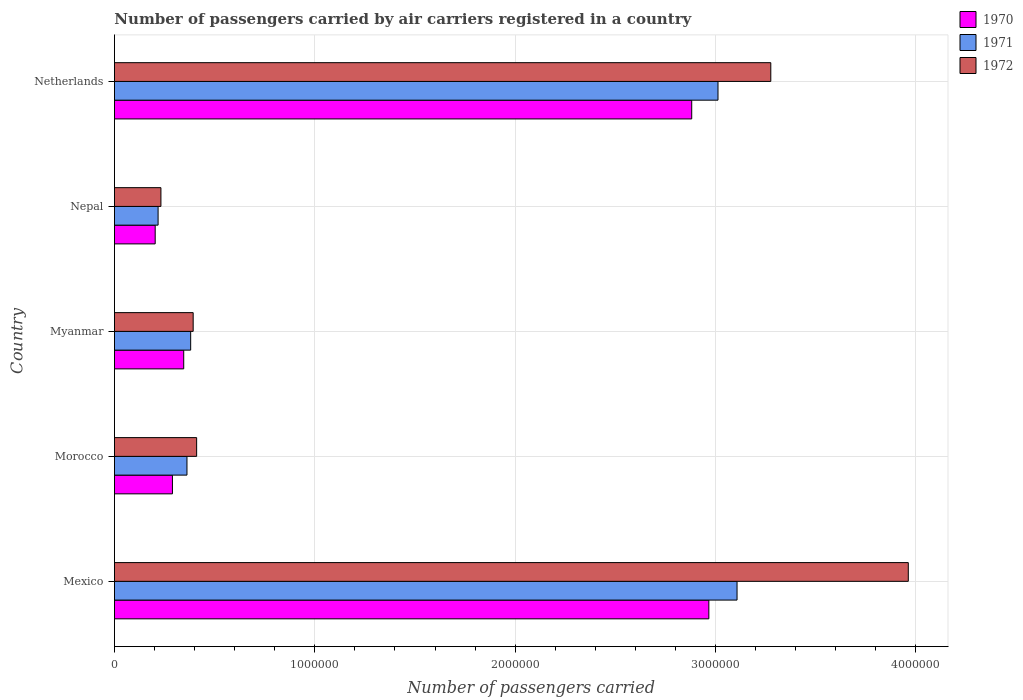How many groups of bars are there?
Offer a very short reply. 5. Are the number of bars per tick equal to the number of legend labels?
Your response must be concise. Yes. Are the number of bars on each tick of the Y-axis equal?
Your answer should be compact. Yes. What is the label of the 3rd group of bars from the top?
Your response must be concise. Myanmar. In how many cases, is the number of bars for a given country not equal to the number of legend labels?
Your answer should be compact. 0. What is the number of passengers carried by air carriers in 1972 in Mexico?
Make the answer very short. 3.96e+06. Across all countries, what is the maximum number of passengers carried by air carriers in 1972?
Give a very brief answer. 3.96e+06. Across all countries, what is the minimum number of passengers carried by air carriers in 1972?
Your answer should be compact. 2.32e+05. In which country was the number of passengers carried by air carriers in 1971 maximum?
Your answer should be compact. Mexico. In which country was the number of passengers carried by air carriers in 1971 minimum?
Your answer should be very brief. Nepal. What is the total number of passengers carried by air carriers in 1972 in the graph?
Your answer should be very brief. 8.27e+06. What is the difference between the number of passengers carried by air carriers in 1970 in Morocco and that in Netherlands?
Give a very brief answer. -2.59e+06. What is the difference between the number of passengers carried by air carriers in 1971 in Nepal and the number of passengers carried by air carriers in 1970 in Mexico?
Your answer should be compact. -2.75e+06. What is the average number of passengers carried by air carriers in 1971 per country?
Provide a short and direct response. 1.42e+06. What is the difference between the number of passengers carried by air carriers in 1972 and number of passengers carried by air carriers in 1970 in Myanmar?
Give a very brief answer. 4.72e+04. In how many countries, is the number of passengers carried by air carriers in 1971 greater than 1000000 ?
Provide a short and direct response. 2. What is the ratio of the number of passengers carried by air carriers in 1971 in Nepal to that in Netherlands?
Offer a very short reply. 0.07. What is the difference between the highest and the second highest number of passengers carried by air carriers in 1972?
Make the answer very short. 6.86e+05. What is the difference between the highest and the lowest number of passengers carried by air carriers in 1971?
Provide a succinct answer. 2.89e+06. In how many countries, is the number of passengers carried by air carriers in 1971 greater than the average number of passengers carried by air carriers in 1971 taken over all countries?
Ensure brevity in your answer.  2. Is the sum of the number of passengers carried by air carriers in 1970 in Mexico and Myanmar greater than the maximum number of passengers carried by air carriers in 1971 across all countries?
Provide a succinct answer. Yes. How many bars are there?
Provide a short and direct response. 15. How many countries are there in the graph?
Make the answer very short. 5. What is the difference between two consecutive major ticks on the X-axis?
Keep it short and to the point. 1.00e+06. Does the graph contain any zero values?
Keep it short and to the point. No. Where does the legend appear in the graph?
Your answer should be compact. Top right. How are the legend labels stacked?
Ensure brevity in your answer.  Vertical. What is the title of the graph?
Keep it short and to the point. Number of passengers carried by air carriers registered in a country. Does "1974" appear as one of the legend labels in the graph?
Keep it short and to the point. No. What is the label or title of the X-axis?
Give a very brief answer. Number of passengers carried. What is the Number of passengers carried of 1970 in Mexico?
Your answer should be compact. 2.97e+06. What is the Number of passengers carried in 1971 in Mexico?
Your answer should be very brief. 3.11e+06. What is the Number of passengers carried of 1972 in Mexico?
Keep it short and to the point. 3.96e+06. What is the Number of passengers carried in 1970 in Morocco?
Your response must be concise. 2.90e+05. What is the Number of passengers carried of 1971 in Morocco?
Make the answer very short. 3.62e+05. What is the Number of passengers carried in 1972 in Morocco?
Your answer should be compact. 4.10e+05. What is the Number of passengers carried in 1970 in Myanmar?
Keep it short and to the point. 3.46e+05. What is the Number of passengers carried in 1971 in Myanmar?
Provide a succinct answer. 3.80e+05. What is the Number of passengers carried in 1972 in Myanmar?
Your answer should be very brief. 3.93e+05. What is the Number of passengers carried of 1970 in Nepal?
Your response must be concise. 2.03e+05. What is the Number of passengers carried in 1971 in Nepal?
Offer a very short reply. 2.18e+05. What is the Number of passengers carried of 1972 in Nepal?
Ensure brevity in your answer.  2.32e+05. What is the Number of passengers carried of 1970 in Netherlands?
Provide a succinct answer. 2.88e+06. What is the Number of passengers carried of 1971 in Netherlands?
Offer a terse response. 3.01e+06. What is the Number of passengers carried in 1972 in Netherlands?
Your answer should be compact. 3.28e+06. Across all countries, what is the maximum Number of passengers carried in 1970?
Offer a terse response. 2.97e+06. Across all countries, what is the maximum Number of passengers carried of 1971?
Offer a very short reply. 3.11e+06. Across all countries, what is the maximum Number of passengers carried of 1972?
Offer a very short reply. 3.96e+06. Across all countries, what is the minimum Number of passengers carried in 1970?
Your response must be concise. 2.03e+05. Across all countries, what is the minimum Number of passengers carried in 1971?
Ensure brevity in your answer.  2.18e+05. Across all countries, what is the minimum Number of passengers carried in 1972?
Offer a terse response. 2.32e+05. What is the total Number of passengers carried of 1970 in the graph?
Provide a succinct answer. 6.69e+06. What is the total Number of passengers carried in 1971 in the graph?
Offer a very short reply. 7.08e+06. What is the total Number of passengers carried of 1972 in the graph?
Give a very brief answer. 8.27e+06. What is the difference between the Number of passengers carried in 1970 in Mexico and that in Morocco?
Offer a very short reply. 2.68e+06. What is the difference between the Number of passengers carried in 1971 in Mexico and that in Morocco?
Provide a succinct answer. 2.75e+06. What is the difference between the Number of passengers carried in 1972 in Mexico and that in Morocco?
Offer a very short reply. 3.55e+06. What is the difference between the Number of passengers carried of 1970 in Mexico and that in Myanmar?
Provide a short and direct response. 2.62e+06. What is the difference between the Number of passengers carried in 1971 in Mexico and that in Myanmar?
Provide a succinct answer. 2.73e+06. What is the difference between the Number of passengers carried of 1972 in Mexico and that in Myanmar?
Provide a succinct answer. 3.57e+06. What is the difference between the Number of passengers carried in 1970 in Mexico and that in Nepal?
Offer a terse response. 2.76e+06. What is the difference between the Number of passengers carried in 1971 in Mexico and that in Nepal?
Your answer should be compact. 2.89e+06. What is the difference between the Number of passengers carried of 1972 in Mexico and that in Nepal?
Ensure brevity in your answer.  3.73e+06. What is the difference between the Number of passengers carried in 1970 in Mexico and that in Netherlands?
Provide a succinct answer. 8.55e+04. What is the difference between the Number of passengers carried in 1971 in Mexico and that in Netherlands?
Offer a very short reply. 9.50e+04. What is the difference between the Number of passengers carried of 1972 in Mexico and that in Netherlands?
Keep it short and to the point. 6.86e+05. What is the difference between the Number of passengers carried in 1970 in Morocco and that in Myanmar?
Offer a terse response. -5.63e+04. What is the difference between the Number of passengers carried in 1971 in Morocco and that in Myanmar?
Provide a succinct answer. -1.85e+04. What is the difference between the Number of passengers carried in 1972 in Morocco and that in Myanmar?
Keep it short and to the point. 1.73e+04. What is the difference between the Number of passengers carried of 1970 in Morocco and that in Nepal?
Ensure brevity in your answer.  8.61e+04. What is the difference between the Number of passengers carried of 1971 in Morocco and that in Nepal?
Offer a terse response. 1.44e+05. What is the difference between the Number of passengers carried of 1972 in Morocco and that in Nepal?
Your answer should be compact. 1.78e+05. What is the difference between the Number of passengers carried of 1970 in Morocco and that in Netherlands?
Ensure brevity in your answer.  -2.59e+06. What is the difference between the Number of passengers carried of 1971 in Morocco and that in Netherlands?
Your answer should be very brief. -2.65e+06. What is the difference between the Number of passengers carried of 1972 in Morocco and that in Netherlands?
Keep it short and to the point. -2.87e+06. What is the difference between the Number of passengers carried of 1970 in Myanmar and that in Nepal?
Keep it short and to the point. 1.42e+05. What is the difference between the Number of passengers carried in 1971 in Myanmar and that in Nepal?
Offer a terse response. 1.63e+05. What is the difference between the Number of passengers carried in 1972 in Myanmar and that in Nepal?
Your answer should be very brief. 1.61e+05. What is the difference between the Number of passengers carried in 1970 in Myanmar and that in Netherlands?
Offer a terse response. -2.54e+06. What is the difference between the Number of passengers carried in 1971 in Myanmar and that in Netherlands?
Make the answer very short. -2.63e+06. What is the difference between the Number of passengers carried in 1972 in Myanmar and that in Netherlands?
Make the answer very short. -2.88e+06. What is the difference between the Number of passengers carried in 1970 in Nepal and that in Netherlands?
Your answer should be compact. -2.68e+06. What is the difference between the Number of passengers carried of 1971 in Nepal and that in Netherlands?
Your answer should be very brief. -2.79e+06. What is the difference between the Number of passengers carried of 1972 in Nepal and that in Netherlands?
Provide a short and direct response. -3.04e+06. What is the difference between the Number of passengers carried in 1970 in Mexico and the Number of passengers carried in 1971 in Morocco?
Provide a short and direct response. 2.60e+06. What is the difference between the Number of passengers carried in 1970 in Mexico and the Number of passengers carried in 1972 in Morocco?
Your response must be concise. 2.56e+06. What is the difference between the Number of passengers carried of 1971 in Mexico and the Number of passengers carried of 1972 in Morocco?
Keep it short and to the point. 2.70e+06. What is the difference between the Number of passengers carried in 1970 in Mexico and the Number of passengers carried in 1971 in Myanmar?
Your answer should be compact. 2.59e+06. What is the difference between the Number of passengers carried of 1970 in Mexico and the Number of passengers carried of 1972 in Myanmar?
Ensure brevity in your answer.  2.57e+06. What is the difference between the Number of passengers carried of 1971 in Mexico and the Number of passengers carried of 1972 in Myanmar?
Offer a very short reply. 2.71e+06. What is the difference between the Number of passengers carried of 1970 in Mexico and the Number of passengers carried of 1971 in Nepal?
Give a very brief answer. 2.75e+06. What is the difference between the Number of passengers carried of 1970 in Mexico and the Number of passengers carried of 1972 in Nepal?
Make the answer very short. 2.73e+06. What is the difference between the Number of passengers carried of 1971 in Mexico and the Number of passengers carried of 1972 in Nepal?
Ensure brevity in your answer.  2.88e+06. What is the difference between the Number of passengers carried in 1970 in Mexico and the Number of passengers carried in 1971 in Netherlands?
Give a very brief answer. -4.57e+04. What is the difference between the Number of passengers carried of 1970 in Mexico and the Number of passengers carried of 1972 in Netherlands?
Offer a very short reply. -3.09e+05. What is the difference between the Number of passengers carried in 1971 in Mexico and the Number of passengers carried in 1972 in Netherlands?
Ensure brevity in your answer.  -1.68e+05. What is the difference between the Number of passengers carried of 1970 in Morocco and the Number of passengers carried of 1971 in Myanmar?
Offer a very short reply. -9.10e+04. What is the difference between the Number of passengers carried in 1970 in Morocco and the Number of passengers carried in 1972 in Myanmar?
Your answer should be very brief. -1.04e+05. What is the difference between the Number of passengers carried of 1971 in Morocco and the Number of passengers carried of 1972 in Myanmar?
Your answer should be compact. -3.10e+04. What is the difference between the Number of passengers carried of 1970 in Morocco and the Number of passengers carried of 1971 in Nepal?
Keep it short and to the point. 7.16e+04. What is the difference between the Number of passengers carried of 1970 in Morocco and the Number of passengers carried of 1972 in Nepal?
Provide a succinct answer. 5.75e+04. What is the difference between the Number of passengers carried in 1970 in Morocco and the Number of passengers carried in 1971 in Netherlands?
Your response must be concise. -2.72e+06. What is the difference between the Number of passengers carried in 1970 in Morocco and the Number of passengers carried in 1972 in Netherlands?
Ensure brevity in your answer.  -2.99e+06. What is the difference between the Number of passengers carried in 1971 in Morocco and the Number of passengers carried in 1972 in Netherlands?
Your response must be concise. -2.91e+06. What is the difference between the Number of passengers carried of 1970 in Myanmar and the Number of passengers carried of 1971 in Nepal?
Your answer should be very brief. 1.28e+05. What is the difference between the Number of passengers carried in 1970 in Myanmar and the Number of passengers carried in 1972 in Nepal?
Keep it short and to the point. 1.14e+05. What is the difference between the Number of passengers carried in 1971 in Myanmar and the Number of passengers carried in 1972 in Nepal?
Provide a succinct answer. 1.48e+05. What is the difference between the Number of passengers carried of 1970 in Myanmar and the Number of passengers carried of 1971 in Netherlands?
Give a very brief answer. -2.67e+06. What is the difference between the Number of passengers carried in 1970 in Myanmar and the Number of passengers carried in 1972 in Netherlands?
Your answer should be very brief. -2.93e+06. What is the difference between the Number of passengers carried in 1971 in Myanmar and the Number of passengers carried in 1972 in Netherlands?
Ensure brevity in your answer.  -2.90e+06. What is the difference between the Number of passengers carried in 1970 in Nepal and the Number of passengers carried in 1971 in Netherlands?
Make the answer very short. -2.81e+06. What is the difference between the Number of passengers carried in 1970 in Nepal and the Number of passengers carried in 1972 in Netherlands?
Provide a succinct answer. -3.07e+06. What is the difference between the Number of passengers carried in 1971 in Nepal and the Number of passengers carried in 1972 in Netherlands?
Give a very brief answer. -3.06e+06. What is the average Number of passengers carried of 1970 per country?
Give a very brief answer. 1.34e+06. What is the average Number of passengers carried in 1971 per country?
Offer a terse response. 1.42e+06. What is the average Number of passengers carried in 1972 per country?
Ensure brevity in your answer.  1.65e+06. What is the difference between the Number of passengers carried of 1970 and Number of passengers carried of 1971 in Mexico?
Your answer should be compact. -1.41e+05. What is the difference between the Number of passengers carried of 1970 and Number of passengers carried of 1972 in Mexico?
Make the answer very short. -9.95e+05. What is the difference between the Number of passengers carried of 1971 and Number of passengers carried of 1972 in Mexico?
Provide a succinct answer. -8.55e+05. What is the difference between the Number of passengers carried of 1970 and Number of passengers carried of 1971 in Morocco?
Provide a succinct answer. -7.25e+04. What is the difference between the Number of passengers carried in 1970 and Number of passengers carried in 1972 in Morocco?
Offer a very short reply. -1.21e+05. What is the difference between the Number of passengers carried in 1971 and Number of passengers carried in 1972 in Morocco?
Provide a succinct answer. -4.83e+04. What is the difference between the Number of passengers carried in 1970 and Number of passengers carried in 1971 in Myanmar?
Your response must be concise. -3.47e+04. What is the difference between the Number of passengers carried of 1970 and Number of passengers carried of 1972 in Myanmar?
Offer a very short reply. -4.72e+04. What is the difference between the Number of passengers carried in 1971 and Number of passengers carried in 1972 in Myanmar?
Provide a short and direct response. -1.25e+04. What is the difference between the Number of passengers carried in 1970 and Number of passengers carried in 1971 in Nepal?
Give a very brief answer. -1.45e+04. What is the difference between the Number of passengers carried in 1970 and Number of passengers carried in 1972 in Nepal?
Your answer should be compact. -2.86e+04. What is the difference between the Number of passengers carried in 1971 and Number of passengers carried in 1972 in Nepal?
Provide a succinct answer. -1.41e+04. What is the difference between the Number of passengers carried in 1970 and Number of passengers carried in 1971 in Netherlands?
Your response must be concise. -1.31e+05. What is the difference between the Number of passengers carried of 1970 and Number of passengers carried of 1972 in Netherlands?
Ensure brevity in your answer.  -3.95e+05. What is the difference between the Number of passengers carried in 1971 and Number of passengers carried in 1972 in Netherlands?
Give a very brief answer. -2.64e+05. What is the ratio of the Number of passengers carried in 1970 in Mexico to that in Morocco?
Your answer should be very brief. 10.25. What is the ratio of the Number of passengers carried of 1971 in Mexico to that in Morocco?
Offer a very short reply. 8.58. What is the ratio of the Number of passengers carried in 1972 in Mexico to that in Morocco?
Give a very brief answer. 9.66. What is the ratio of the Number of passengers carried in 1970 in Mexico to that in Myanmar?
Offer a terse response. 8.58. What is the ratio of the Number of passengers carried of 1971 in Mexico to that in Myanmar?
Offer a very short reply. 8.17. What is the ratio of the Number of passengers carried in 1972 in Mexico to that in Myanmar?
Provide a succinct answer. 10.08. What is the ratio of the Number of passengers carried of 1970 in Mexico to that in Nepal?
Keep it short and to the point. 14.59. What is the ratio of the Number of passengers carried in 1971 in Mexico to that in Nepal?
Provide a succinct answer. 14.26. What is the ratio of the Number of passengers carried of 1972 in Mexico to that in Nepal?
Provide a short and direct response. 17.08. What is the ratio of the Number of passengers carried in 1970 in Mexico to that in Netherlands?
Make the answer very short. 1.03. What is the ratio of the Number of passengers carried in 1971 in Mexico to that in Netherlands?
Give a very brief answer. 1.03. What is the ratio of the Number of passengers carried in 1972 in Mexico to that in Netherlands?
Make the answer very short. 1.21. What is the ratio of the Number of passengers carried in 1970 in Morocco to that in Myanmar?
Offer a terse response. 0.84. What is the ratio of the Number of passengers carried in 1971 in Morocco to that in Myanmar?
Ensure brevity in your answer.  0.95. What is the ratio of the Number of passengers carried of 1972 in Morocco to that in Myanmar?
Offer a terse response. 1.04. What is the ratio of the Number of passengers carried of 1970 in Morocco to that in Nepal?
Ensure brevity in your answer.  1.42. What is the ratio of the Number of passengers carried in 1971 in Morocco to that in Nepal?
Provide a succinct answer. 1.66. What is the ratio of the Number of passengers carried of 1972 in Morocco to that in Nepal?
Offer a very short reply. 1.77. What is the ratio of the Number of passengers carried of 1970 in Morocco to that in Netherlands?
Offer a terse response. 0.1. What is the ratio of the Number of passengers carried of 1971 in Morocco to that in Netherlands?
Offer a terse response. 0.12. What is the ratio of the Number of passengers carried in 1972 in Morocco to that in Netherlands?
Ensure brevity in your answer.  0.13. What is the ratio of the Number of passengers carried of 1970 in Myanmar to that in Nepal?
Give a very brief answer. 1.7. What is the ratio of the Number of passengers carried of 1971 in Myanmar to that in Nepal?
Make the answer very short. 1.75. What is the ratio of the Number of passengers carried of 1972 in Myanmar to that in Nepal?
Your answer should be compact. 1.69. What is the ratio of the Number of passengers carried of 1970 in Myanmar to that in Netherlands?
Ensure brevity in your answer.  0.12. What is the ratio of the Number of passengers carried in 1971 in Myanmar to that in Netherlands?
Offer a very short reply. 0.13. What is the ratio of the Number of passengers carried in 1972 in Myanmar to that in Netherlands?
Keep it short and to the point. 0.12. What is the ratio of the Number of passengers carried in 1970 in Nepal to that in Netherlands?
Give a very brief answer. 0.07. What is the ratio of the Number of passengers carried of 1971 in Nepal to that in Netherlands?
Keep it short and to the point. 0.07. What is the ratio of the Number of passengers carried in 1972 in Nepal to that in Netherlands?
Your answer should be compact. 0.07. What is the difference between the highest and the second highest Number of passengers carried of 1970?
Your answer should be very brief. 8.55e+04. What is the difference between the highest and the second highest Number of passengers carried of 1971?
Provide a short and direct response. 9.50e+04. What is the difference between the highest and the second highest Number of passengers carried in 1972?
Ensure brevity in your answer.  6.86e+05. What is the difference between the highest and the lowest Number of passengers carried in 1970?
Provide a short and direct response. 2.76e+06. What is the difference between the highest and the lowest Number of passengers carried of 1971?
Provide a short and direct response. 2.89e+06. What is the difference between the highest and the lowest Number of passengers carried in 1972?
Provide a succinct answer. 3.73e+06. 